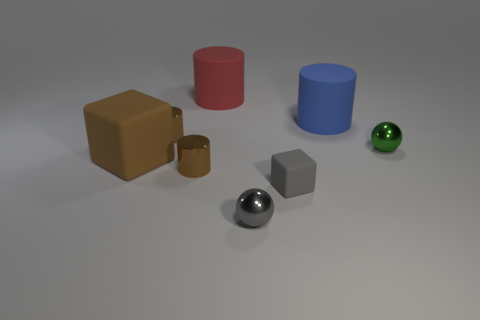Is there any indication of natural light or artificial light in the scene? The scene is illuminated in a manner that suggests the presence of artificial lighting, as indicated by the distinct shadows cast by each object and the soft glow that reflects off the surfaces. 